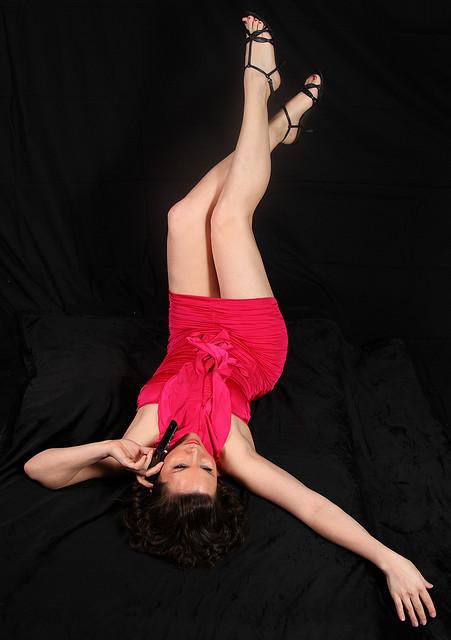Does she look sexy?
Short answer required. Yes. What color dress is she wearing?
Concise answer only. Red. Is this dress pink?
Quick response, please. Yes. 